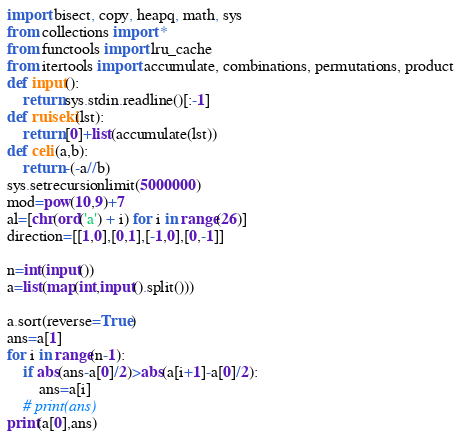<code> <loc_0><loc_0><loc_500><loc_500><_Python_>import bisect, copy, heapq, math, sys
from collections import *
from functools import lru_cache
from itertools import accumulate, combinations, permutations, product
def input():
    return sys.stdin.readline()[:-1]
def ruiseki(lst):
    return [0]+list(accumulate(lst))
def celi(a,b):
    return -(-a//b)
sys.setrecursionlimit(5000000)
mod=pow(10,9)+7
al=[chr(ord('a') + i) for i in range(26)]
direction=[[1,0],[0,1],[-1,0],[0,-1]]

n=int(input())
a=list(map(int,input().split()))

a.sort(reverse=True)
ans=a[1]
for i in range(n-1):
    if abs(ans-a[0]/2)>abs(a[i+1]-a[0]/2):
        ans=a[i]
    # print(ans)
print(a[0],ans)</code> 